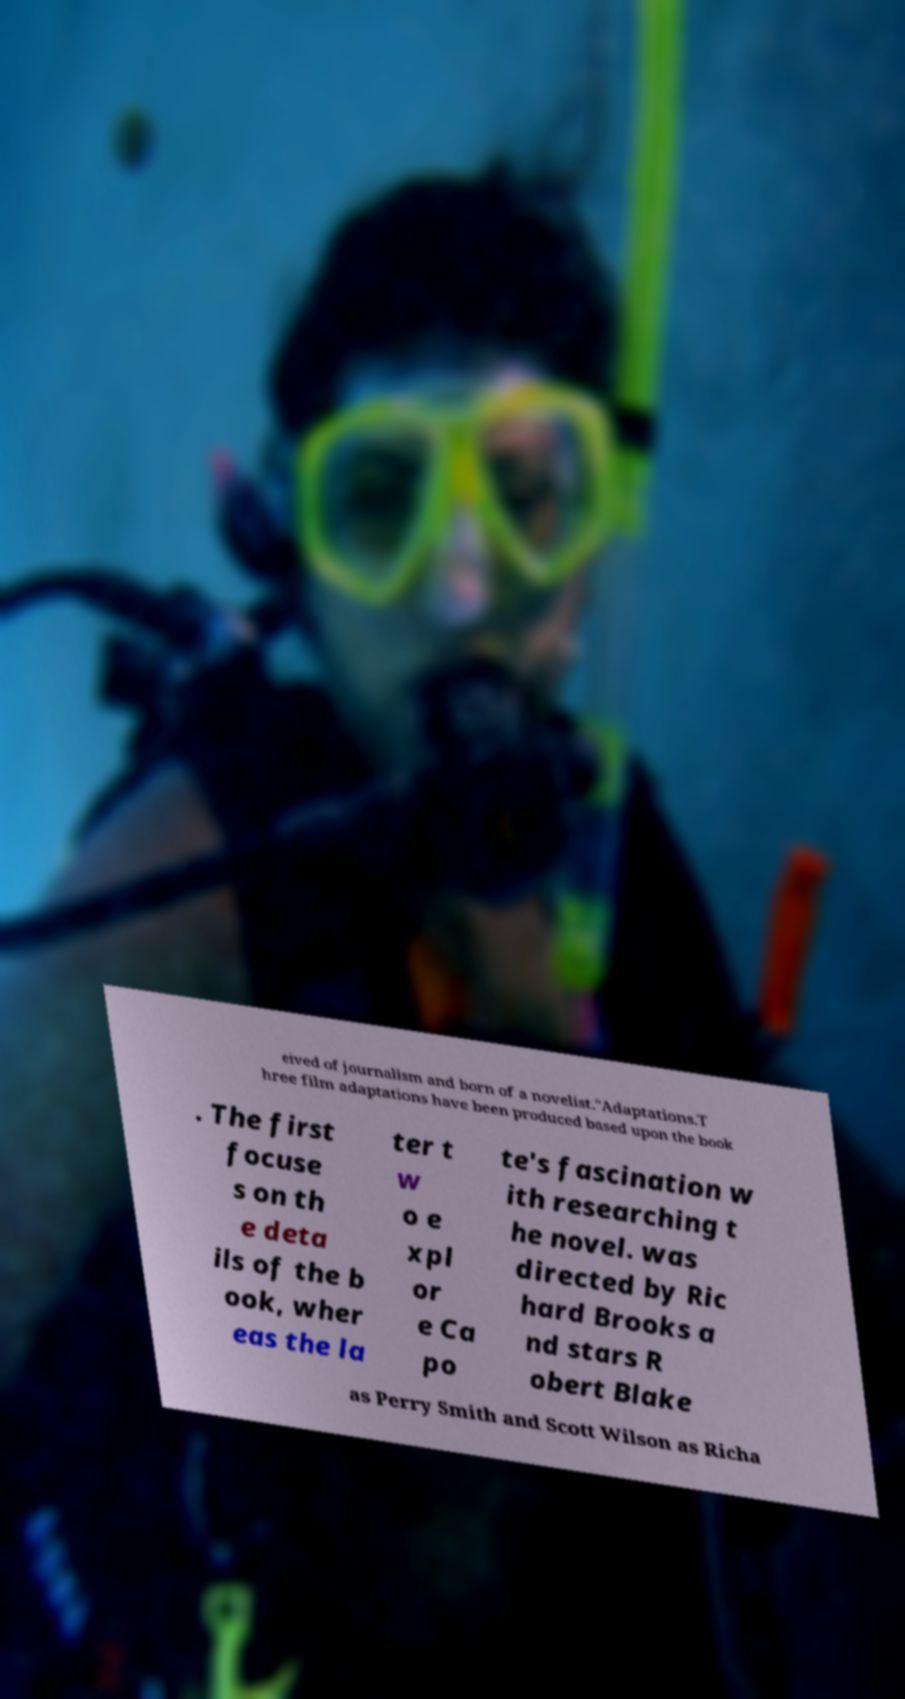Can you read and provide the text displayed in the image?This photo seems to have some interesting text. Can you extract and type it out for me? eived of journalism and born of a novelist."Adaptations.T hree film adaptations have been produced based upon the book . The first focuse s on th e deta ils of the b ook, wher eas the la ter t w o e xpl or e Ca po te's fascination w ith researching t he novel. was directed by Ric hard Brooks a nd stars R obert Blake as Perry Smith and Scott Wilson as Richa 